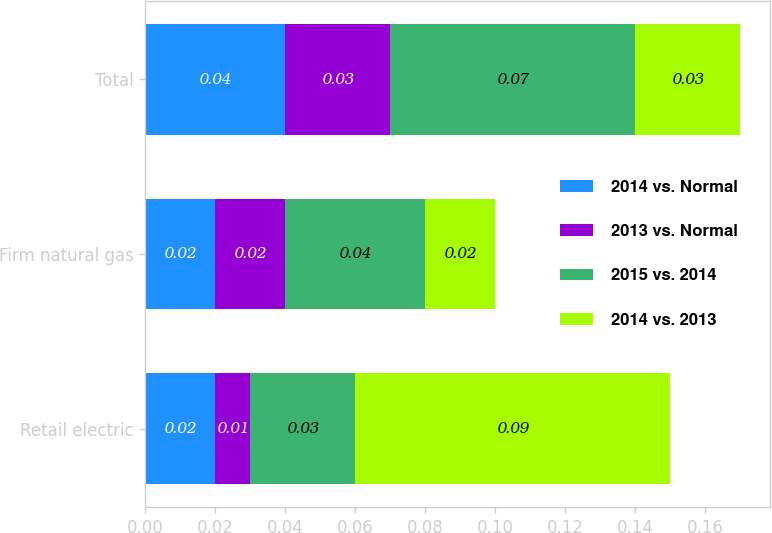<chart> <loc_0><loc_0><loc_500><loc_500><stacked_bar_chart><ecel><fcel>Retail electric<fcel>Firm natural gas<fcel>Total<nl><fcel>2014 vs. Normal<fcel>0.02<fcel>0.02<fcel>0.04<nl><fcel>2013 vs. Normal<fcel>0.01<fcel>0.02<fcel>0.03<nl><fcel>2015 vs. 2014<fcel>0.03<fcel>0.04<fcel>0.07<nl><fcel>2014 vs. 2013<fcel>0.09<fcel>0.02<fcel>0.03<nl></chart> 